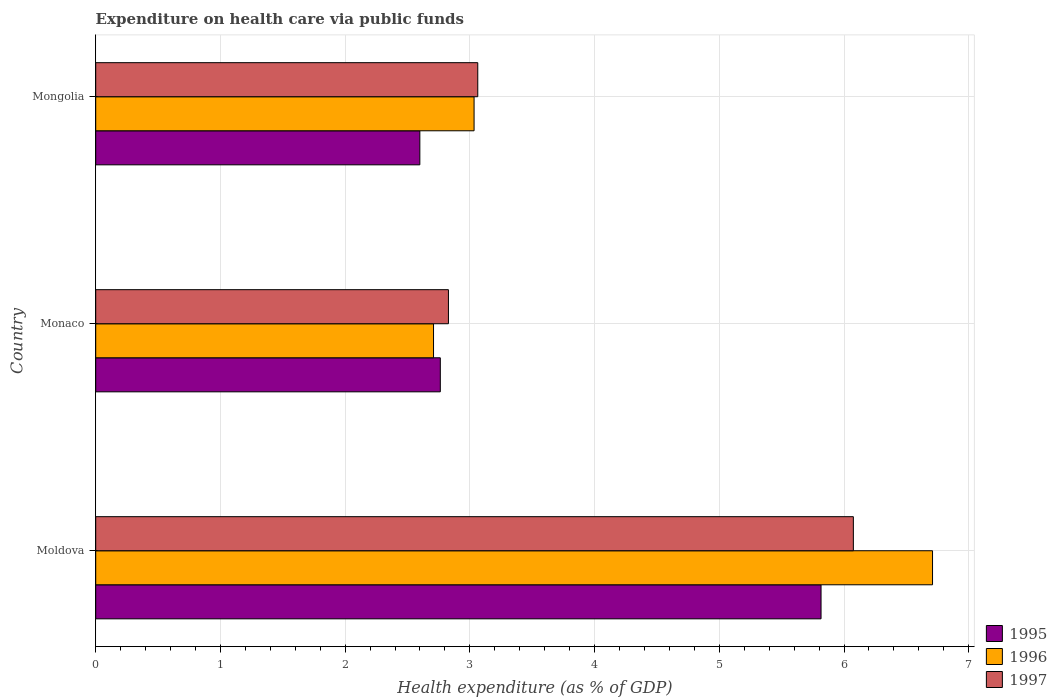How many groups of bars are there?
Offer a very short reply. 3. Are the number of bars on each tick of the Y-axis equal?
Offer a terse response. Yes. How many bars are there on the 1st tick from the bottom?
Make the answer very short. 3. What is the label of the 1st group of bars from the top?
Provide a short and direct response. Mongolia. In how many cases, is the number of bars for a given country not equal to the number of legend labels?
Your response must be concise. 0. What is the expenditure made on health care in 1997 in Moldova?
Make the answer very short. 6.08. Across all countries, what is the maximum expenditure made on health care in 1996?
Provide a short and direct response. 6.71. Across all countries, what is the minimum expenditure made on health care in 1995?
Provide a short and direct response. 2.6. In which country was the expenditure made on health care in 1996 maximum?
Keep it short and to the point. Moldova. In which country was the expenditure made on health care in 1996 minimum?
Make the answer very short. Monaco. What is the total expenditure made on health care in 1996 in the graph?
Ensure brevity in your answer.  12.45. What is the difference between the expenditure made on health care in 1996 in Moldova and that in Mongolia?
Ensure brevity in your answer.  3.68. What is the difference between the expenditure made on health care in 1996 in Monaco and the expenditure made on health care in 1995 in Mongolia?
Your answer should be compact. 0.11. What is the average expenditure made on health care in 1996 per country?
Provide a succinct answer. 4.15. What is the difference between the expenditure made on health care in 1996 and expenditure made on health care in 1997 in Monaco?
Ensure brevity in your answer.  -0.12. In how many countries, is the expenditure made on health care in 1996 greater than 6.4 %?
Your answer should be very brief. 1. What is the ratio of the expenditure made on health care in 1997 in Moldova to that in Mongolia?
Provide a succinct answer. 1.98. Is the expenditure made on health care in 1995 in Moldova less than that in Mongolia?
Make the answer very short. No. Is the difference between the expenditure made on health care in 1996 in Moldova and Monaco greater than the difference between the expenditure made on health care in 1997 in Moldova and Monaco?
Make the answer very short. Yes. What is the difference between the highest and the second highest expenditure made on health care in 1997?
Give a very brief answer. 3.01. What is the difference between the highest and the lowest expenditure made on health care in 1997?
Make the answer very short. 3.25. What does the 3rd bar from the top in Mongolia represents?
Offer a terse response. 1995. What does the 3rd bar from the bottom in Monaco represents?
Ensure brevity in your answer.  1997. Are all the bars in the graph horizontal?
Offer a very short reply. Yes. How many countries are there in the graph?
Provide a short and direct response. 3. Are the values on the major ticks of X-axis written in scientific E-notation?
Your response must be concise. No. Does the graph contain any zero values?
Ensure brevity in your answer.  No. Does the graph contain grids?
Make the answer very short. Yes. What is the title of the graph?
Ensure brevity in your answer.  Expenditure on health care via public funds. Does "2015" appear as one of the legend labels in the graph?
Offer a terse response. No. What is the label or title of the X-axis?
Keep it short and to the point. Health expenditure (as % of GDP). What is the Health expenditure (as % of GDP) of 1995 in Moldova?
Your response must be concise. 5.82. What is the Health expenditure (as % of GDP) of 1996 in Moldova?
Make the answer very short. 6.71. What is the Health expenditure (as % of GDP) in 1997 in Moldova?
Give a very brief answer. 6.08. What is the Health expenditure (as % of GDP) in 1995 in Monaco?
Provide a short and direct response. 2.76. What is the Health expenditure (as % of GDP) of 1996 in Monaco?
Provide a succinct answer. 2.71. What is the Health expenditure (as % of GDP) of 1997 in Monaco?
Your answer should be compact. 2.83. What is the Health expenditure (as % of GDP) in 1995 in Mongolia?
Ensure brevity in your answer.  2.6. What is the Health expenditure (as % of GDP) of 1996 in Mongolia?
Your response must be concise. 3.03. What is the Health expenditure (as % of GDP) of 1997 in Mongolia?
Offer a very short reply. 3.06. Across all countries, what is the maximum Health expenditure (as % of GDP) of 1995?
Keep it short and to the point. 5.82. Across all countries, what is the maximum Health expenditure (as % of GDP) of 1996?
Make the answer very short. 6.71. Across all countries, what is the maximum Health expenditure (as % of GDP) of 1997?
Ensure brevity in your answer.  6.08. Across all countries, what is the minimum Health expenditure (as % of GDP) of 1995?
Keep it short and to the point. 2.6. Across all countries, what is the minimum Health expenditure (as % of GDP) in 1996?
Give a very brief answer. 2.71. Across all countries, what is the minimum Health expenditure (as % of GDP) in 1997?
Make the answer very short. 2.83. What is the total Health expenditure (as % of GDP) in 1995 in the graph?
Provide a succinct answer. 11.18. What is the total Health expenditure (as % of GDP) in 1996 in the graph?
Your answer should be very brief. 12.45. What is the total Health expenditure (as % of GDP) in 1997 in the graph?
Offer a very short reply. 11.97. What is the difference between the Health expenditure (as % of GDP) of 1995 in Moldova and that in Monaco?
Give a very brief answer. 3.05. What is the difference between the Health expenditure (as % of GDP) of 1996 in Moldova and that in Monaco?
Provide a succinct answer. 4. What is the difference between the Health expenditure (as % of GDP) in 1997 in Moldova and that in Monaco?
Give a very brief answer. 3.25. What is the difference between the Health expenditure (as % of GDP) of 1995 in Moldova and that in Mongolia?
Your answer should be very brief. 3.22. What is the difference between the Health expenditure (as % of GDP) of 1996 in Moldova and that in Mongolia?
Your answer should be compact. 3.68. What is the difference between the Health expenditure (as % of GDP) in 1997 in Moldova and that in Mongolia?
Your answer should be very brief. 3.01. What is the difference between the Health expenditure (as % of GDP) in 1995 in Monaco and that in Mongolia?
Your answer should be compact. 0.16. What is the difference between the Health expenditure (as % of GDP) in 1996 in Monaco and that in Mongolia?
Make the answer very short. -0.33. What is the difference between the Health expenditure (as % of GDP) in 1997 in Monaco and that in Mongolia?
Keep it short and to the point. -0.24. What is the difference between the Health expenditure (as % of GDP) in 1995 in Moldova and the Health expenditure (as % of GDP) in 1996 in Monaco?
Make the answer very short. 3.11. What is the difference between the Health expenditure (as % of GDP) of 1995 in Moldova and the Health expenditure (as % of GDP) of 1997 in Monaco?
Give a very brief answer. 2.99. What is the difference between the Health expenditure (as % of GDP) in 1996 in Moldova and the Health expenditure (as % of GDP) in 1997 in Monaco?
Your response must be concise. 3.88. What is the difference between the Health expenditure (as % of GDP) of 1995 in Moldova and the Health expenditure (as % of GDP) of 1996 in Mongolia?
Offer a terse response. 2.78. What is the difference between the Health expenditure (as % of GDP) in 1995 in Moldova and the Health expenditure (as % of GDP) in 1997 in Mongolia?
Offer a very short reply. 2.75. What is the difference between the Health expenditure (as % of GDP) of 1996 in Moldova and the Health expenditure (as % of GDP) of 1997 in Mongolia?
Your answer should be compact. 3.65. What is the difference between the Health expenditure (as % of GDP) of 1995 in Monaco and the Health expenditure (as % of GDP) of 1996 in Mongolia?
Provide a short and direct response. -0.27. What is the difference between the Health expenditure (as % of GDP) of 1995 in Monaco and the Health expenditure (as % of GDP) of 1997 in Mongolia?
Ensure brevity in your answer.  -0.3. What is the difference between the Health expenditure (as % of GDP) in 1996 in Monaco and the Health expenditure (as % of GDP) in 1997 in Mongolia?
Keep it short and to the point. -0.35. What is the average Health expenditure (as % of GDP) of 1995 per country?
Your answer should be compact. 3.73. What is the average Health expenditure (as % of GDP) of 1996 per country?
Your answer should be very brief. 4.15. What is the average Health expenditure (as % of GDP) of 1997 per country?
Make the answer very short. 3.99. What is the difference between the Health expenditure (as % of GDP) of 1995 and Health expenditure (as % of GDP) of 1996 in Moldova?
Your response must be concise. -0.89. What is the difference between the Health expenditure (as % of GDP) of 1995 and Health expenditure (as % of GDP) of 1997 in Moldova?
Give a very brief answer. -0.26. What is the difference between the Health expenditure (as % of GDP) of 1996 and Health expenditure (as % of GDP) of 1997 in Moldova?
Offer a very short reply. 0.63. What is the difference between the Health expenditure (as % of GDP) of 1995 and Health expenditure (as % of GDP) of 1996 in Monaco?
Your response must be concise. 0.05. What is the difference between the Health expenditure (as % of GDP) in 1995 and Health expenditure (as % of GDP) in 1997 in Monaco?
Make the answer very short. -0.07. What is the difference between the Health expenditure (as % of GDP) in 1996 and Health expenditure (as % of GDP) in 1997 in Monaco?
Offer a terse response. -0.12. What is the difference between the Health expenditure (as % of GDP) in 1995 and Health expenditure (as % of GDP) in 1996 in Mongolia?
Offer a terse response. -0.43. What is the difference between the Health expenditure (as % of GDP) in 1995 and Health expenditure (as % of GDP) in 1997 in Mongolia?
Your answer should be compact. -0.46. What is the difference between the Health expenditure (as % of GDP) of 1996 and Health expenditure (as % of GDP) of 1997 in Mongolia?
Offer a very short reply. -0.03. What is the ratio of the Health expenditure (as % of GDP) of 1995 in Moldova to that in Monaco?
Offer a terse response. 2.1. What is the ratio of the Health expenditure (as % of GDP) in 1996 in Moldova to that in Monaco?
Provide a short and direct response. 2.48. What is the ratio of the Health expenditure (as % of GDP) of 1997 in Moldova to that in Monaco?
Offer a very short reply. 2.15. What is the ratio of the Health expenditure (as % of GDP) of 1995 in Moldova to that in Mongolia?
Make the answer very short. 2.24. What is the ratio of the Health expenditure (as % of GDP) in 1996 in Moldova to that in Mongolia?
Ensure brevity in your answer.  2.21. What is the ratio of the Health expenditure (as % of GDP) in 1997 in Moldova to that in Mongolia?
Your response must be concise. 1.98. What is the ratio of the Health expenditure (as % of GDP) of 1995 in Monaco to that in Mongolia?
Keep it short and to the point. 1.06. What is the ratio of the Health expenditure (as % of GDP) of 1996 in Monaco to that in Mongolia?
Keep it short and to the point. 0.89. What is the ratio of the Health expenditure (as % of GDP) in 1997 in Monaco to that in Mongolia?
Offer a very short reply. 0.92. What is the difference between the highest and the second highest Health expenditure (as % of GDP) in 1995?
Keep it short and to the point. 3.05. What is the difference between the highest and the second highest Health expenditure (as % of GDP) in 1996?
Ensure brevity in your answer.  3.68. What is the difference between the highest and the second highest Health expenditure (as % of GDP) in 1997?
Provide a short and direct response. 3.01. What is the difference between the highest and the lowest Health expenditure (as % of GDP) of 1995?
Your answer should be very brief. 3.22. What is the difference between the highest and the lowest Health expenditure (as % of GDP) of 1996?
Give a very brief answer. 4. What is the difference between the highest and the lowest Health expenditure (as % of GDP) of 1997?
Offer a very short reply. 3.25. 